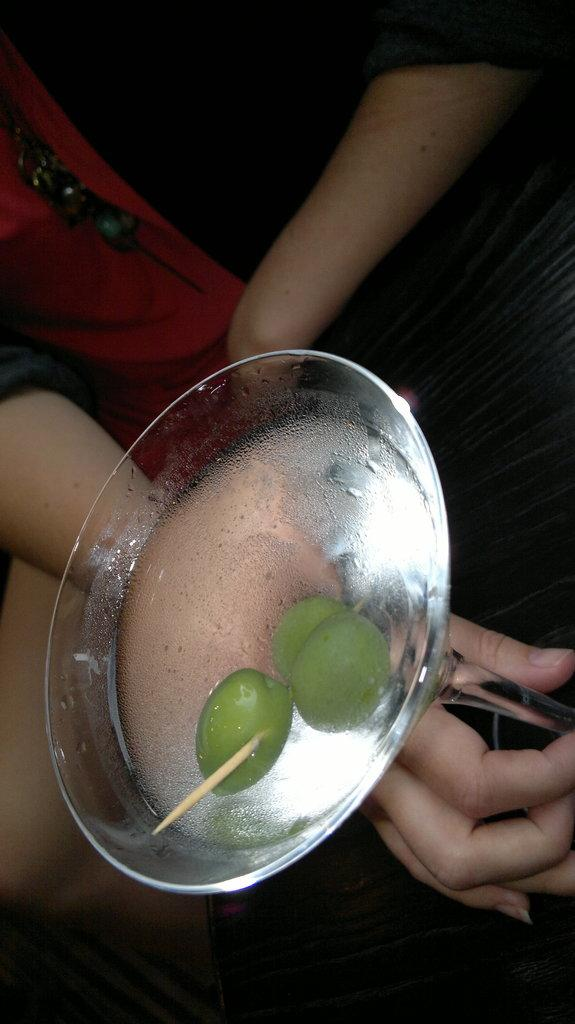Who or what is present in the image? There is a person in the image. What object can be seen in the image besides the person? There is a table in the image. What is on the table? There is a glass on the table. What is inside the glass? There are lemons and water in the glass. How many birds are flying over the person in the image? There are no birds present in the image. 